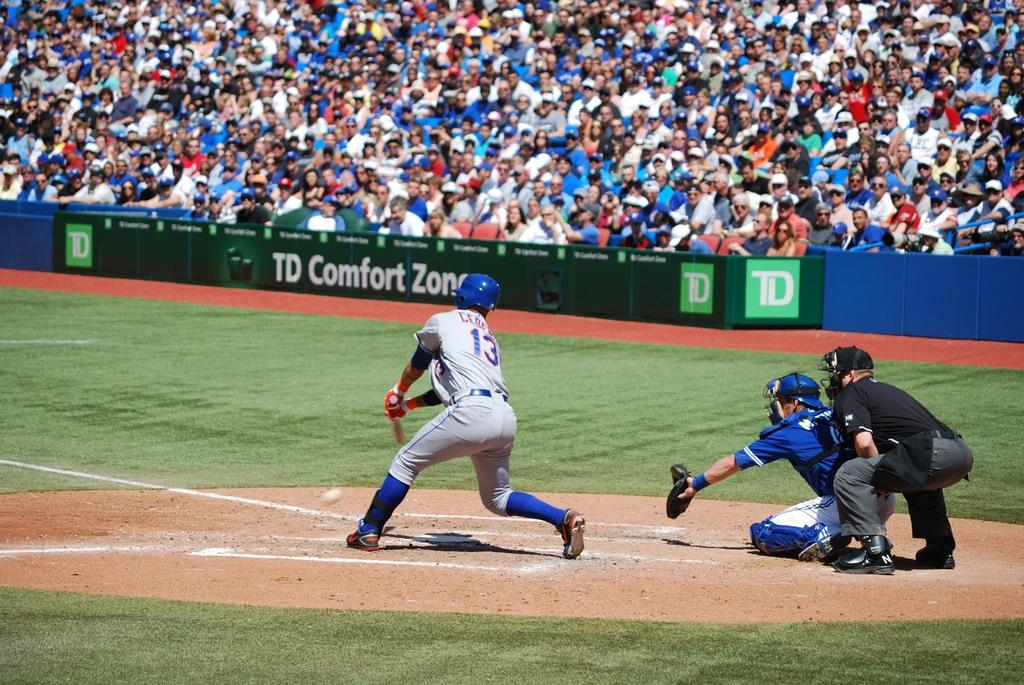<image>
Describe the image concisely. Baseball stadium with green banner in front of fans that has TD Comfort Zone. 